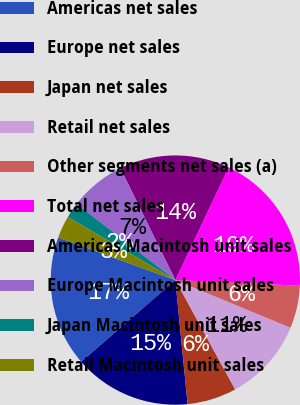Convert chart. <chart><loc_0><loc_0><loc_500><loc_500><pie_chart><fcel>Americas net sales<fcel>Europe net sales<fcel>Japan net sales<fcel>Retail net sales<fcel>Other segments net sales (a)<fcel>Total net sales<fcel>Americas Macintosh unit sales<fcel>Europe Macintosh unit sales<fcel>Japan Macintosh unit sales<fcel>Retail Macintosh unit sales<nl><fcel>16.94%<fcel>15.18%<fcel>6.4%<fcel>10.79%<fcel>5.52%<fcel>18.7%<fcel>14.3%<fcel>7.28%<fcel>2.01%<fcel>2.89%<nl></chart> 